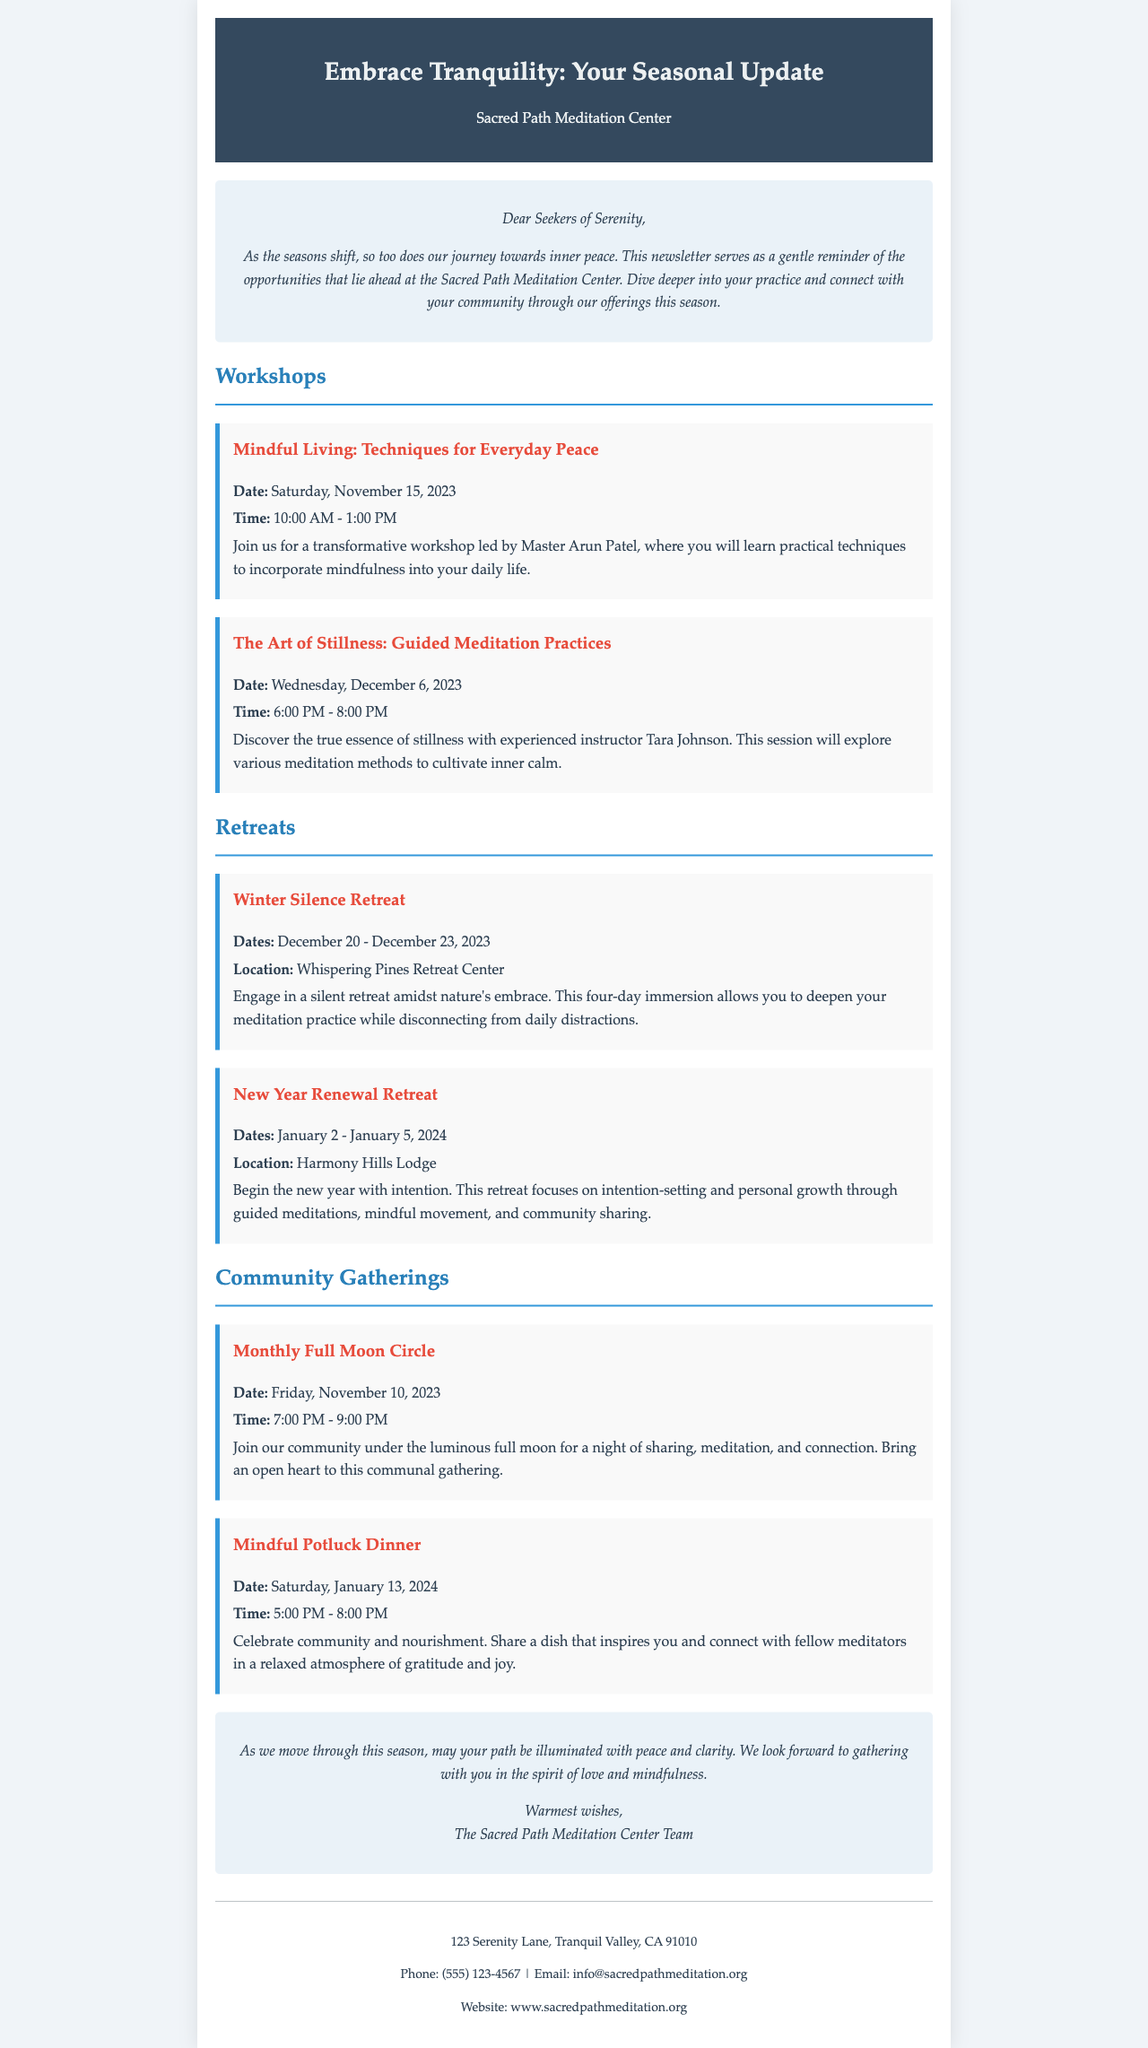what is the title of the newsletter? The title of the newsletter is clearly stated at the top of the document, which is "Embrace Tranquility: Your Seasonal Update from the Sacred Path Meditation Center."
Answer: Embrace Tranquility: Your Seasonal Update who is leading the workshop on Mindful Living? The document lists Master Arun Patel as the facilitator for the "Mindful Living: Techniques for Everyday Peace" workshop.
Answer: Master Arun Patel when does the Winter Silence Retreat begin? The start date for the Winter Silence Retreat is provided in the document, which is December 20, 2023.
Answer: December 20, 2023 what is the location of the New Year Renewal Retreat? The document specifies that the New Year Renewal Retreat will take place at Harmony Hills Lodge.
Answer: Harmony Hills Lodge how long will the Monthly Full Moon Circle last? The time frame for the Monthly Full Moon Circle, as stated in the schedule, is from 7:00 PM to 9:00 PM.
Answer: 2 hours what is the main theme of the New Year Renewal Retreat? The document mentions that the focus of the New Year Renewal Retreat is on intention-setting and personal growth.
Answer: Intention-setting and personal growth which community gathering involves sharing a meal? The document notes that the "Mindful Potluck Dinner" is a community gathering where attendees share a dish.
Answer: Mindful Potluck Dinner what is the contact phone number for the meditation center? The contact information includes the phone number, which is listed in the closing section of the document.
Answer: (555) 123-4567 